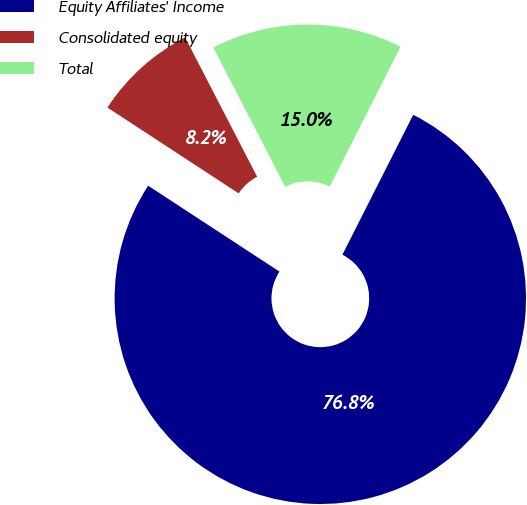Convert chart to OTSL. <chart><loc_0><loc_0><loc_500><loc_500><pie_chart><fcel>Equity Affiliates' Income<fcel>Consolidated equity<fcel>Total<nl><fcel>76.76%<fcel>8.19%<fcel>15.05%<nl></chart> 